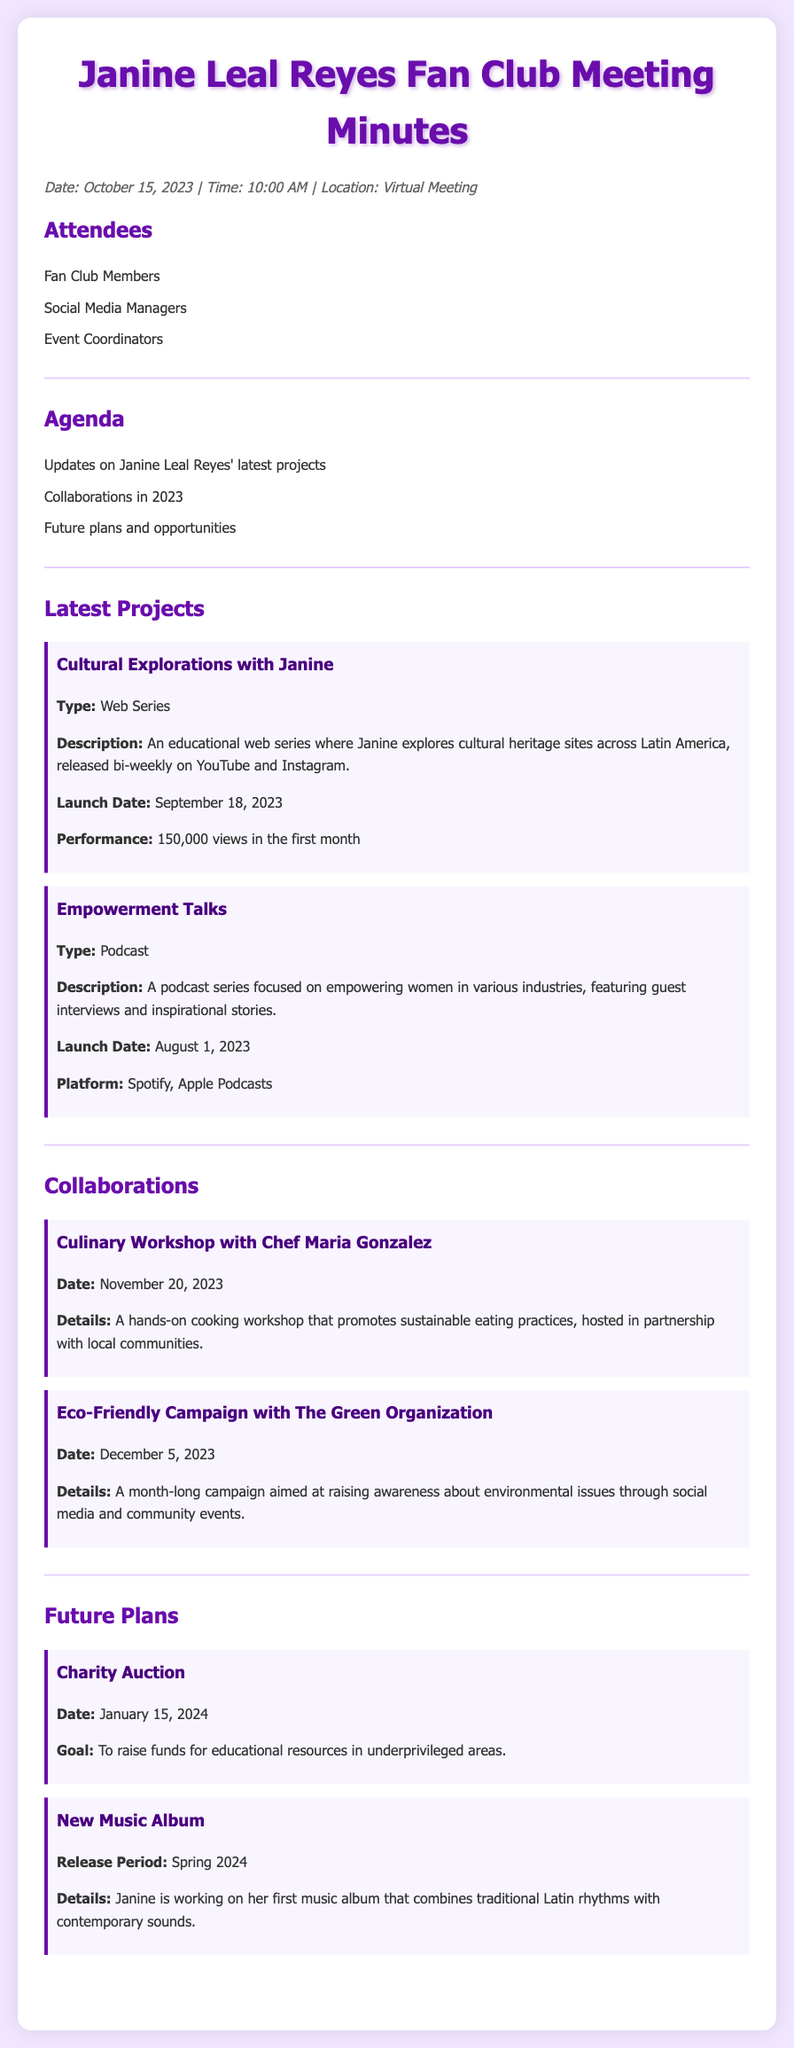What is the launch date of the web series "Cultural Explorations with Janine"? The launch date is provided in the document as September 18, 2023.
Answer: September 18, 2023 How many views did "Cultural Explorations with Janine" receive in the first month? The document states that it received 150,000 views in the first month.
Answer: 150,000 views What is the date of the Culinary Workshop? The date for the Culinary Workshop with Chef Maria Gonzalez is mentioned in the document as November 20, 2023.
Answer: November 20, 2023 What type of project is "Empowerment Talks"? The document categorizes "Empowerment Talks" as a podcast series.
Answer: Podcast What is the goal of the Charity Auction? The goal for the Charity Auction is to raise funds for educational resources in underprivileged areas as mentioned in the document.
Answer: Funds for educational resources What platform is the "Empowerment Talks" podcast available on? The document lists Spotify and Apple Podcasts as the platforms for the podcast series.
Answer: Spotify, Apple Podcasts What is the primary focus of the podcast series "Empowerment Talks"? The primary focus is on empowering women in various industries as described in the document.
Answer: Empowering women Which organization is Janine collaborating with for the Eco-Friendly Campaign? The document identifies "The Green Organization" as the partner for the Eco-Friendly Campaign.
Answer: The Green Organization What type of content does the web series "Cultural Explorations with Janine" feature? The content focuses on exploring cultural heritage sites across Latin America according to the document.
Answer: Cultural heritage sites 